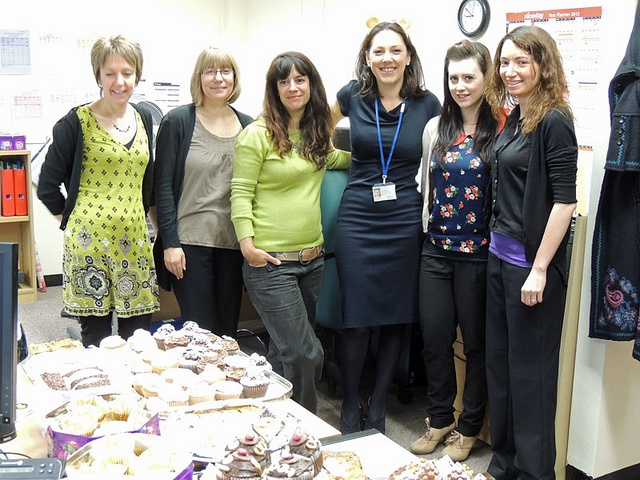Describe the objects in this image and their specific colors. I can see people in white, black, gray, tan, and ivory tones, people in white, black, navy, gray, and blue tones, people in white, black, gray, and navy tones, people in white, black, gray, khaki, and olive tones, and people in white, black, olive, khaki, and ivory tones in this image. 